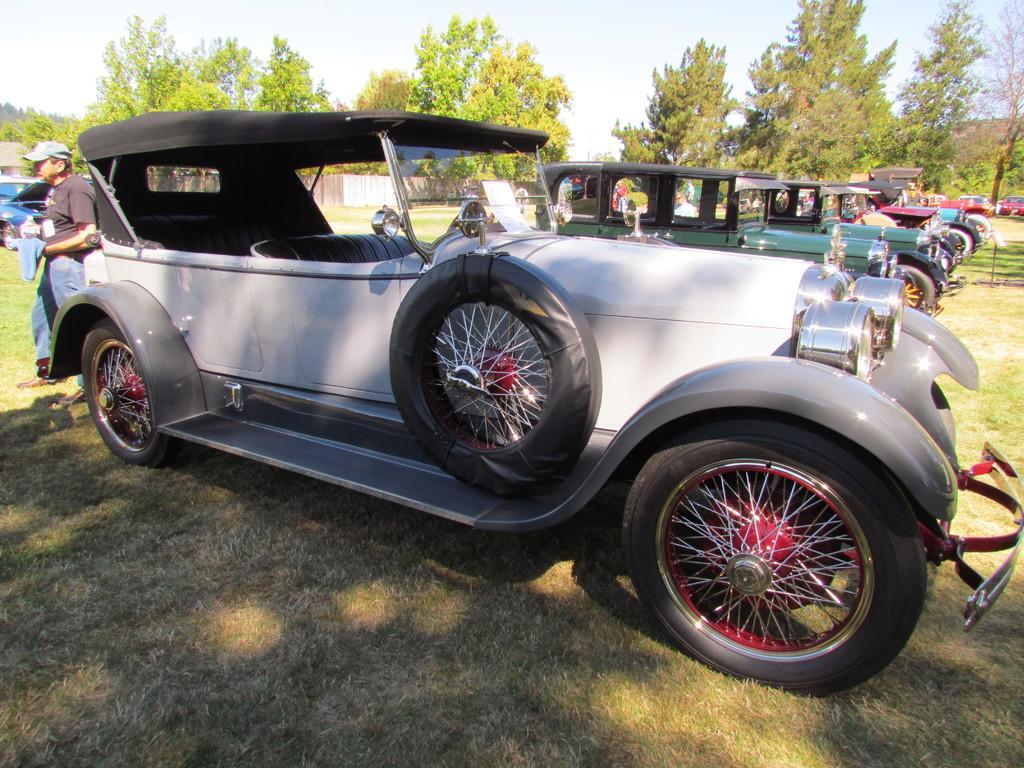How would you summarize this image in a sentence or two? In this image, we can see some cars. There is a person on the left side of the image standing and wearing clothes. In the background of the image, there are some trees and sky. 